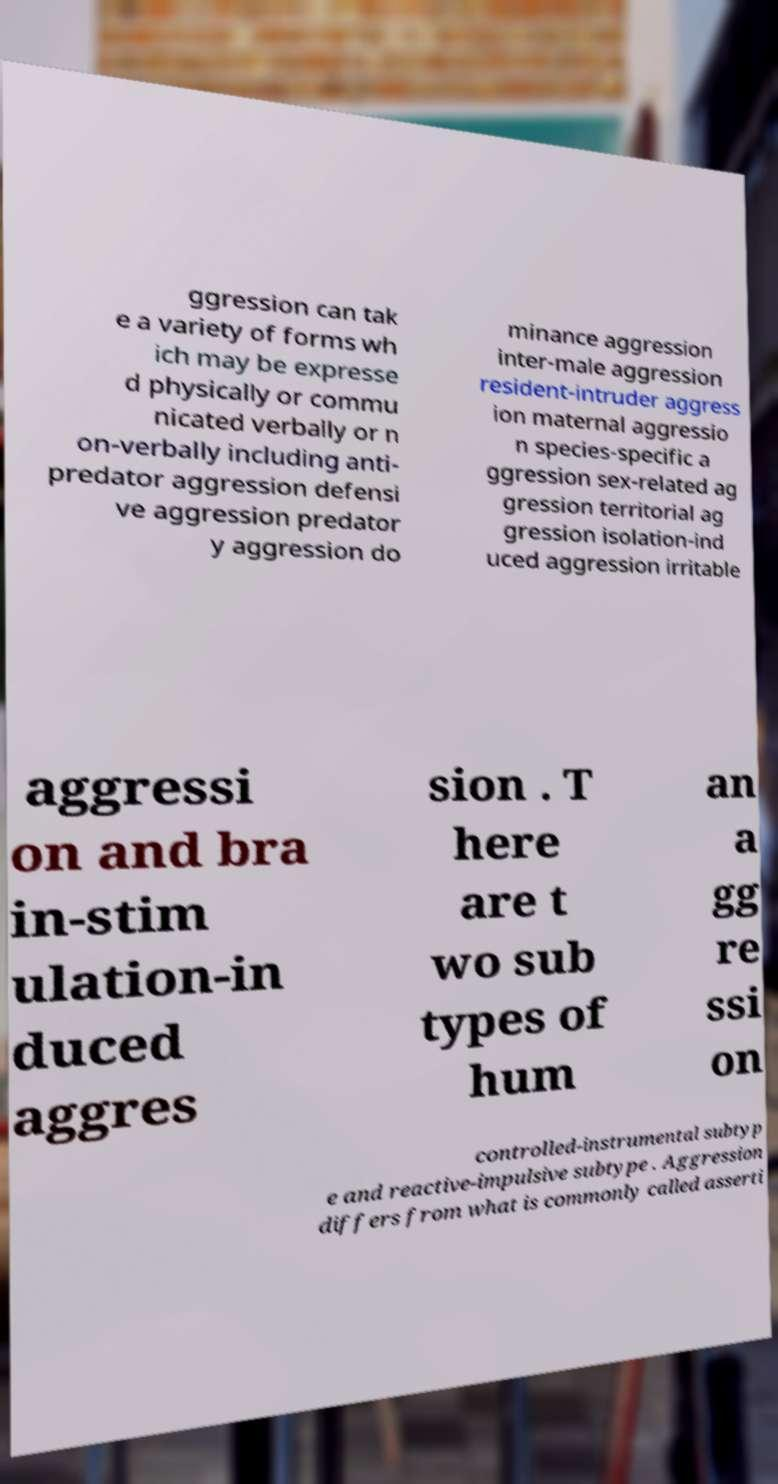Could you extract and type out the text from this image? ggression can tak e a variety of forms wh ich may be expresse d physically or commu nicated verbally or n on-verbally including anti- predator aggression defensi ve aggression predator y aggression do minance aggression inter-male aggression resident-intruder aggress ion maternal aggressio n species-specific a ggression sex-related ag gression territorial ag gression isolation-ind uced aggression irritable aggressi on and bra in-stim ulation-in duced aggres sion . T here are t wo sub types of hum an a gg re ssi on controlled-instrumental subtyp e and reactive-impulsive subtype . Aggression differs from what is commonly called asserti 